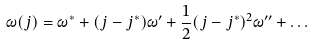<formula> <loc_0><loc_0><loc_500><loc_500>\omega ( j ) = \omega ^ { * } + ( j - j ^ { * } ) \omega ^ { \prime } + \frac { 1 } { 2 } ( j - j ^ { * } ) ^ { 2 } \omega ^ { \prime \prime } + \dots</formula> 